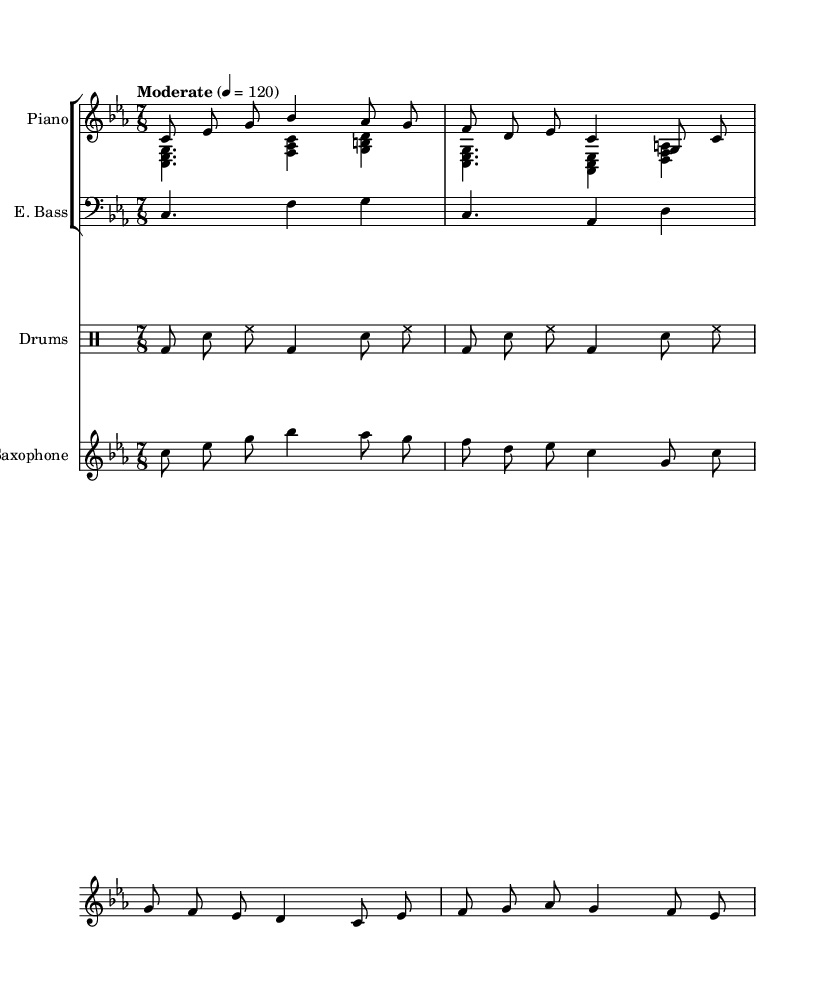What is the key signature of this music? The key signature is C minor, which features three flats (B flat, E flat, and A flat). This is determined by the 'key c \minor' notation in the global part of the code.
Answer: C minor What is the time signature of this piece? The time signature is 7/8, indicated by the '\time 7/8' directive in the global part of the code. This means there are seven eighth notes in each measure.
Answer: 7/8 What is the tempo marking of the piece? The tempo marking indicates "Moderate" at a speed of quarter note equals 120 beats per minute, as defined by the '\tempo "Moderate" 4 = 120' notation in the global section.
Answer: Moderate, 120 How many voices are used in the piano part? There are two voices in the piano part, specified by '\new Voice = "pianoRH"' for the right hand and '\new Voice = "pianoLH"' for the left hand. Each voice can play independently within the same staff.
Answer: Two Which instruments are present in this score? The score includes Piano, Electric Bass, Drums, and Saxophone, as inferred from the individual staff setups and their respective instrument names listed in the score.
Answer: Piano, Electric Bass, Drums, Saxophone What rhythmic pattern do the drums primarily use? The drums primarily use a repeating pattern of bass drum and snare, which is indicated by the dashes for the bass drum and the "sn" for the snare in the drummode section of the code. This illustrates a typical jazz rhythm.
Answer: Bass drum and snare What complex musical technique is used with the saxophone part? The saxophone part employs an improvisational style characteristic of jazz, utilizing a melody line that interacts rhythmically with the underlying harmonic changes, shown by its syncopated rhythms and melodic variations.
Answer: Improvisation 